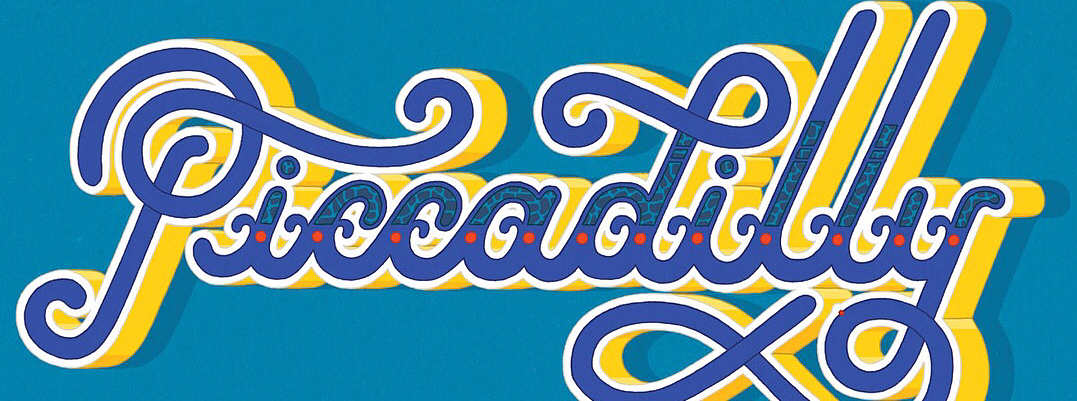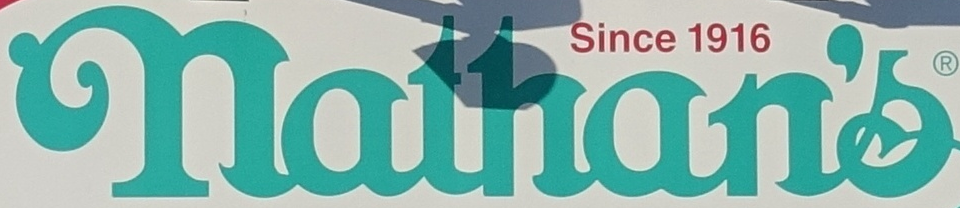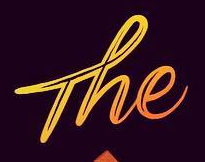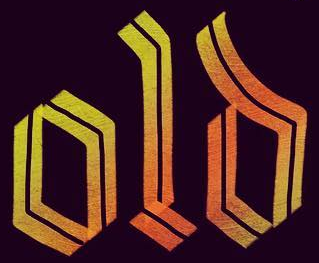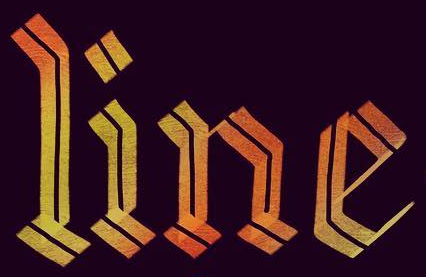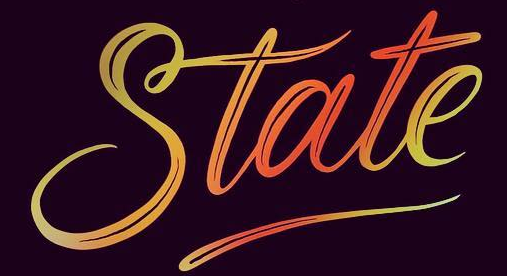Read the text from these images in sequence, separated by a semicolon. Piccadilly; nathan's; The; old; line; State 